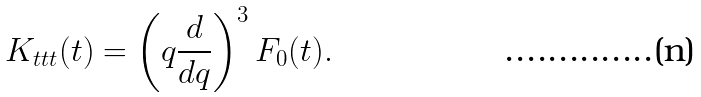<formula> <loc_0><loc_0><loc_500><loc_500>K _ { t t t } ( t ) = \left ( q \frac { d } { d q } \right ) ^ { 3 } F _ { 0 } ( t ) .</formula> 